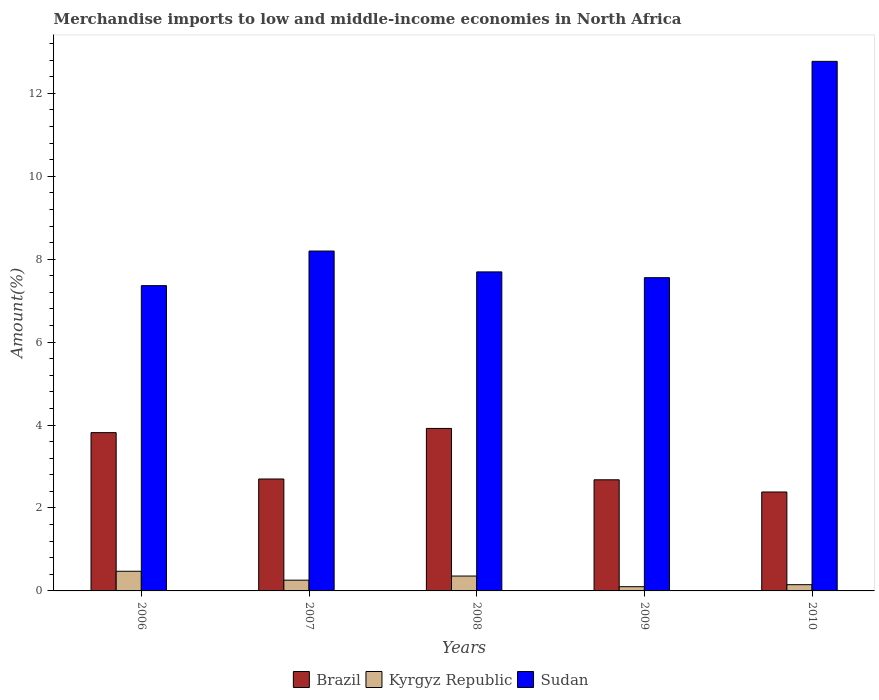How many different coloured bars are there?
Offer a terse response. 3. How many groups of bars are there?
Offer a terse response. 5. Are the number of bars per tick equal to the number of legend labels?
Your answer should be very brief. Yes. How many bars are there on the 4th tick from the left?
Give a very brief answer. 3. How many bars are there on the 5th tick from the right?
Give a very brief answer. 3. In how many cases, is the number of bars for a given year not equal to the number of legend labels?
Offer a terse response. 0. What is the percentage of amount earned from merchandise imports in Sudan in 2009?
Give a very brief answer. 7.55. Across all years, what is the maximum percentage of amount earned from merchandise imports in Kyrgyz Republic?
Your answer should be compact. 0.47. Across all years, what is the minimum percentage of amount earned from merchandise imports in Kyrgyz Republic?
Make the answer very short. 0.1. In which year was the percentage of amount earned from merchandise imports in Kyrgyz Republic maximum?
Your answer should be compact. 2006. What is the total percentage of amount earned from merchandise imports in Brazil in the graph?
Ensure brevity in your answer.  15.5. What is the difference between the percentage of amount earned from merchandise imports in Brazil in 2008 and that in 2010?
Provide a succinct answer. 1.53. What is the difference between the percentage of amount earned from merchandise imports in Sudan in 2009 and the percentage of amount earned from merchandise imports in Kyrgyz Republic in 2006?
Your answer should be very brief. 7.08. What is the average percentage of amount earned from merchandise imports in Kyrgyz Republic per year?
Give a very brief answer. 0.27. In the year 2010, what is the difference between the percentage of amount earned from merchandise imports in Sudan and percentage of amount earned from merchandise imports in Brazil?
Provide a succinct answer. 10.38. What is the ratio of the percentage of amount earned from merchandise imports in Kyrgyz Republic in 2008 to that in 2009?
Ensure brevity in your answer.  3.51. Is the difference between the percentage of amount earned from merchandise imports in Sudan in 2006 and 2008 greater than the difference between the percentage of amount earned from merchandise imports in Brazil in 2006 and 2008?
Ensure brevity in your answer.  No. What is the difference between the highest and the second highest percentage of amount earned from merchandise imports in Brazil?
Keep it short and to the point. 0.1. What is the difference between the highest and the lowest percentage of amount earned from merchandise imports in Brazil?
Provide a short and direct response. 1.53. What does the 2nd bar from the left in 2010 represents?
Offer a terse response. Kyrgyz Republic. Are all the bars in the graph horizontal?
Your answer should be compact. No. What is the difference between two consecutive major ticks on the Y-axis?
Provide a succinct answer. 2. Are the values on the major ticks of Y-axis written in scientific E-notation?
Offer a terse response. No. Does the graph contain any zero values?
Offer a very short reply. No. Does the graph contain grids?
Ensure brevity in your answer.  No. What is the title of the graph?
Give a very brief answer. Merchandise imports to low and middle-income economies in North Africa. What is the label or title of the X-axis?
Provide a short and direct response. Years. What is the label or title of the Y-axis?
Your answer should be very brief. Amount(%). What is the Amount(%) of Brazil in 2006?
Keep it short and to the point. 3.82. What is the Amount(%) in Kyrgyz Republic in 2006?
Keep it short and to the point. 0.47. What is the Amount(%) in Sudan in 2006?
Your response must be concise. 7.36. What is the Amount(%) in Brazil in 2007?
Keep it short and to the point. 2.7. What is the Amount(%) in Kyrgyz Republic in 2007?
Provide a short and direct response. 0.26. What is the Amount(%) of Sudan in 2007?
Offer a very short reply. 8.2. What is the Amount(%) of Brazil in 2008?
Ensure brevity in your answer.  3.92. What is the Amount(%) of Kyrgyz Republic in 2008?
Ensure brevity in your answer.  0.36. What is the Amount(%) of Sudan in 2008?
Keep it short and to the point. 7.69. What is the Amount(%) of Brazil in 2009?
Your response must be concise. 2.68. What is the Amount(%) in Kyrgyz Republic in 2009?
Offer a very short reply. 0.1. What is the Amount(%) in Sudan in 2009?
Your answer should be very brief. 7.55. What is the Amount(%) of Brazil in 2010?
Give a very brief answer. 2.39. What is the Amount(%) in Kyrgyz Republic in 2010?
Give a very brief answer. 0.15. What is the Amount(%) of Sudan in 2010?
Give a very brief answer. 12.77. Across all years, what is the maximum Amount(%) in Brazil?
Your answer should be very brief. 3.92. Across all years, what is the maximum Amount(%) in Kyrgyz Republic?
Make the answer very short. 0.47. Across all years, what is the maximum Amount(%) in Sudan?
Provide a short and direct response. 12.77. Across all years, what is the minimum Amount(%) in Brazil?
Give a very brief answer. 2.39. Across all years, what is the minimum Amount(%) of Kyrgyz Republic?
Keep it short and to the point. 0.1. Across all years, what is the minimum Amount(%) in Sudan?
Offer a very short reply. 7.36. What is the total Amount(%) in Brazil in the graph?
Keep it short and to the point. 15.5. What is the total Amount(%) in Kyrgyz Republic in the graph?
Make the answer very short. 1.34. What is the total Amount(%) of Sudan in the graph?
Offer a terse response. 43.58. What is the difference between the Amount(%) in Brazil in 2006 and that in 2007?
Provide a succinct answer. 1.12. What is the difference between the Amount(%) of Kyrgyz Republic in 2006 and that in 2007?
Your answer should be very brief. 0.21. What is the difference between the Amount(%) in Sudan in 2006 and that in 2007?
Make the answer very short. -0.83. What is the difference between the Amount(%) of Brazil in 2006 and that in 2008?
Offer a very short reply. -0.1. What is the difference between the Amount(%) of Kyrgyz Republic in 2006 and that in 2008?
Provide a succinct answer. 0.12. What is the difference between the Amount(%) in Sudan in 2006 and that in 2008?
Your response must be concise. -0.33. What is the difference between the Amount(%) in Brazil in 2006 and that in 2009?
Offer a very short reply. 1.14. What is the difference between the Amount(%) in Kyrgyz Republic in 2006 and that in 2009?
Your response must be concise. 0.37. What is the difference between the Amount(%) of Sudan in 2006 and that in 2009?
Your answer should be very brief. -0.19. What is the difference between the Amount(%) of Brazil in 2006 and that in 2010?
Your answer should be very brief. 1.43. What is the difference between the Amount(%) in Kyrgyz Republic in 2006 and that in 2010?
Provide a short and direct response. 0.32. What is the difference between the Amount(%) in Sudan in 2006 and that in 2010?
Your response must be concise. -5.41. What is the difference between the Amount(%) of Brazil in 2007 and that in 2008?
Give a very brief answer. -1.22. What is the difference between the Amount(%) of Kyrgyz Republic in 2007 and that in 2008?
Ensure brevity in your answer.  -0.1. What is the difference between the Amount(%) in Sudan in 2007 and that in 2008?
Offer a terse response. 0.5. What is the difference between the Amount(%) in Brazil in 2007 and that in 2009?
Provide a succinct answer. 0.02. What is the difference between the Amount(%) of Kyrgyz Republic in 2007 and that in 2009?
Your response must be concise. 0.16. What is the difference between the Amount(%) in Sudan in 2007 and that in 2009?
Offer a terse response. 0.64. What is the difference between the Amount(%) of Brazil in 2007 and that in 2010?
Your answer should be very brief. 0.31. What is the difference between the Amount(%) in Kyrgyz Republic in 2007 and that in 2010?
Your answer should be very brief. 0.11. What is the difference between the Amount(%) in Sudan in 2007 and that in 2010?
Your answer should be very brief. -4.57. What is the difference between the Amount(%) in Brazil in 2008 and that in 2009?
Provide a succinct answer. 1.24. What is the difference between the Amount(%) of Kyrgyz Republic in 2008 and that in 2009?
Your answer should be compact. 0.26. What is the difference between the Amount(%) in Sudan in 2008 and that in 2009?
Make the answer very short. 0.14. What is the difference between the Amount(%) of Brazil in 2008 and that in 2010?
Ensure brevity in your answer.  1.53. What is the difference between the Amount(%) of Kyrgyz Republic in 2008 and that in 2010?
Keep it short and to the point. 0.21. What is the difference between the Amount(%) in Sudan in 2008 and that in 2010?
Ensure brevity in your answer.  -5.08. What is the difference between the Amount(%) in Brazil in 2009 and that in 2010?
Your answer should be very brief. 0.29. What is the difference between the Amount(%) in Kyrgyz Republic in 2009 and that in 2010?
Offer a very short reply. -0.05. What is the difference between the Amount(%) of Sudan in 2009 and that in 2010?
Keep it short and to the point. -5.22. What is the difference between the Amount(%) of Brazil in 2006 and the Amount(%) of Kyrgyz Republic in 2007?
Make the answer very short. 3.56. What is the difference between the Amount(%) of Brazil in 2006 and the Amount(%) of Sudan in 2007?
Provide a succinct answer. -4.38. What is the difference between the Amount(%) of Kyrgyz Republic in 2006 and the Amount(%) of Sudan in 2007?
Ensure brevity in your answer.  -7.72. What is the difference between the Amount(%) of Brazil in 2006 and the Amount(%) of Kyrgyz Republic in 2008?
Ensure brevity in your answer.  3.46. What is the difference between the Amount(%) of Brazil in 2006 and the Amount(%) of Sudan in 2008?
Offer a terse response. -3.88. What is the difference between the Amount(%) of Kyrgyz Republic in 2006 and the Amount(%) of Sudan in 2008?
Keep it short and to the point. -7.22. What is the difference between the Amount(%) of Brazil in 2006 and the Amount(%) of Kyrgyz Republic in 2009?
Your response must be concise. 3.71. What is the difference between the Amount(%) in Brazil in 2006 and the Amount(%) in Sudan in 2009?
Give a very brief answer. -3.74. What is the difference between the Amount(%) of Kyrgyz Republic in 2006 and the Amount(%) of Sudan in 2009?
Provide a short and direct response. -7.08. What is the difference between the Amount(%) of Brazil in 2006 and the Amount(%) of Kyrgyz Republic in 2010?
Make the answer very short. 3.67. What is the difference between the Amount(%) in Brazil in 2006 and the Amount(%) in Sudan in 2010?
Offer a very short reply. -8.95. What is the difference between the Amount(%) of Kyrgyz Republic in 2006 and the Amount(%) of Sudan in 2010?
Ensure brevity in your answer.  -12.3. What is the difference between the Amount(%) in Brazil in 2007 and the Amount(%) in Kyrgyz Republic in 2008?
Your answer should be compact. 2.34. What is the difference between the Amount(%) of Brazil in 2007 and the Amount(%) of Sudan in 2008?
Ensure brevity in your answer.  -4.99. What is the difference between the Amount(%) of Kyrgyz Republic in 2007 and the Amount(%) of Sudan in 2008?
Ensure brevity in your answer.  -7.43. What is the difference between the Amount(%) of Brazil in 2007 and the Amount(%) of Kyrgyz Republic in 2009?
Offer a terse response. 2.6. What is the difference between the Amount(%) of Brazil in 2007 and the Amount(%) of Sudan in 2009?
Make the answer very short. -4.85. What is the difference between the Amount(%) in Kyrgyz Republic in 2007 and the Amount(%) in Sudan in 2009?
Make the answer very short. -7.29. What is the difference between the Amount(%) in Brazil in 2007 and the Amount(%) in Kyrgyz Republic in 2010?
Ensure brevity in your answer.  2.55. What is the difference between the Amount(%) in Brazil in 2007 and the Amount(%) in Sudan in 2010?
Ensure brevity in your answer.  -10.07. What is the difference between the Amount(%) in Kyrgyz Republic in 2007 and the Amount(%) in Sudan in 2010?
Provide a succinct answer. -12.51. What is the difference between the Amount(%) of Brazil in 2008 and the Amount(%) of Kyrgyz Republic in 2009?
Make the answer very short. 3.82. What is the difference between the Amount(%) of Brazil in 2008 and the Amount(%) of Sudan in 2009?
Provide a short and direct response. -3.64. What is the difference between the Amount(%) in Kyrgyz Republic in 2008 and the Amount(%) in Sudan in 2009?
Your answer should be very brief. -7.2. What is the difference between the Amount(%) in Brazil in 2008 and the Amount(%) in Kyrgyz Republic in 2010?
Keep it short and to the point. 3.77. What is the difference between the Amount(%) in Brazil in 2008 and the Amount(%) in Sudan in 2010?
Make the answer very short. -8.85. What is the difference between the Amount(%) in Kyrgyz Republic in 2008 and the Amount(%) in Sudan in 2010?
Make the answer very short. -12.41. What is the difference between the Amount(%) of Brazil in 2009 and the Amount(%) of Kyrgyz Republic in 2010?
Make the answer very short. 2.53. What is the difference between the Amount(%) in Brazil in 2009 and the Amount(%) in Sudan in 2010?
Offer a very short reply. -10.09. What is the difference between the Amount(%) of Kyrgyz Republic in 2009 and the Amount(%) of Sudan in 2010?
Provide a succinct answer. -12.67. What is the average Amount(%) of Brazil per year?
Make the answer very short. 3.1. What is the average Amount(%) in Kyrgyz Republic per year?
Offer a terse response. 0.27. What is the average Amount(%) in Sudan per year?
Your answer should be very brief. 8.72. In the year 2006, what is the difference between the Amount(%) in Brazil and Amount(%) in Kyrgyz Republic?
Your answer should be compact. 3.34. In the year 2006, what is the difference between the Amount(%) of Brazil and Amount(%) of Sudan?
Offer a terse response. -3.54. In the year 2006, what is the difference between the Amount(%) of Kyrgyz Republic and Amount(%) of Sudan?
Your answer should be very brief. -6.89. In the year 2007, what is the difference between the Amount(%) of Brazil and Amount(%) of Kyrgyz Republic?
Make the answer very short. 2.44. In the year 2007, what is the difference between the Amount(%) in Brazil and Amount(%) in Sudan?
Give a very brief answer. -5.5. In the year 2007, what is the difference between the Amount(%) in Kyrgyz Republic and Amount(%) in Sudan?
Provide a short and direct response. -7.94. In the year 2008, what is the difference between the Amount(%) in Brazil and Amount(%) in Kyrgyz Republic?
Your answer should be very brief. 3.56. In the year 2008, what is the difference between the Amount(%) in Brazil and Amount(%) in Sudan?
Make the answer very short. -3.77. In the year 2008, what is the difference between the Amount(%) of Kyrgyz Republic and Amount(%) of Sudan?
Provide a succinct answer. -7.33. In the year 2009, what is the difference between the Amount(%) in Brazil and Amount(%) in Kyrgyz Republic?
Keep it short and to the point. 2.58. In the year 2009, what is the difference between the Amount(%) of Brazil and Amount(%) of Sudan?
Make the answer very short. -4.87. In the year 2009, what is the difference between the Amount(%) of Kyrgyz Republic and Amount(%) of Sudan?
Your answer should be very brief. -7.45. In the year 2010, what is the difference between the Amount(%) in Brazil and Amount(%) in Kyrgyz Republic?
Ensure brevity in your answer.  2.24. In the year 2010, what is the difference between the Amount(%) of Brazil and Amount(%) of Sudan?
Ensure brevity in your answer.  -10.38. In the year 2010, what is the difference between the Amount(%) in Kyrgyz Republic and Amount(%) in Sudan?
Keep it short and to the point. -12.62. What is the ratio of the Amount(%) of Brazil in 2006 to that in 2007?
Provide a short and direct response. 1.41. What is the ratio of the Amount(%) in Kyrgyz Republic in 2006 to that in 2007?
Offer a very short reply. 1.83. What is the ratio of the Amount(%) in Sudan in 2006 to that in 2007?
Provide a succinct answer. 0.9. What is the ratio of the Amount(%) in Brazil in 2006 to that in 2008?
Keep it short and to the point. 0.97. What is the ratio of the Amount(%) in Kyrgyz Republic in 2006 to that in 2008?
Offer a terse response. 1.32. What is the ratio of the Amount(%) of Sudan in 2006 to that in 2008?
Offer a very short reply. 0.96. What is the ratio of the Amount(%) of Brazil in 2006 to that in 2009?
Ensure brevity in your answer.  1.42. What is the ratio of the Amount(%) in Kyrgyz Republic in 2006 to that in 2009?
Offer a very short reply. 4.64. What is the ratio of the Amount(%) in Sudan in 2006 to that in 2009?
Ensure brevity in your answer.  0.97. What is the ratio of the Amount(%) of Brazil in 2006 to that in 2010?
Offer a terse response. 1.6. What is the ratio of the Amount(%) of Kyrgyz Republic in 2006 to that in 2010?
Your answer should be compact. 3.15. What is the ratio of the Amount(%) of Sudan in 2006 to that in 2010?
Offer a very short reply. 0.58. What is the ratio of the Amount(%) in Brazil in 2007 to that in 2008?
Provide a short and direct response. 0.69. What is the ratio of the Amount(%) in Kyrgyz Republic in 2007 to that in 2008?
Offer a terse response. 0.72. What is the ratio of the Amount(%) in Sudan in 2007 to that in 2008?
Ensure brevity in your answer.  1.07. What is the ratio of the Amount(%) in Brazil in 2007 to that in 2009?
Offer a very short reply. 1.01. What is the ratio of the Amount(%) in Kyrgyz Republic in 2007 to that in 2009?
Give a very brief answer. 2.54. What is the ratio of the Amount(%) in Sudan in 2007 to that in 2009?
Your answer should be compact. 1.08. What is the ratio of the Amount(%) in Brazil in 2007 to that in 2010?
Your answer should be compact. 1.13. What is the ratio of the Amount(%) of Kyrgyz Republic in 2007 to that in 2010?
Provide a succinct answer. 1.72. What is the ratio of the Amount(%) in Sudan in 2007 to that in 2010?
Keep it short and to the point. 0.64. What is the ratio of the Amount(%) of Brazil in 2008 to that in 2009?
Your answer should be very brief. 1.46. What is the ratio of the Amount(%) in Kyrgyz Republic in 2008 to that in 2009?
Your response must be concise. 3.51. What is the ratio of the Amount(%) of Sudan in 2008 to that in 2009?
Your answer should be compact. 1.02. What is the ratio of the Amount(%) in Brazil in 2008 to that in 2010?
Offer a very short reply. 1.64. What is the ratio of the Amount(%) in Kyrgyz Republic in 2008 to that in 2010?
Your response must be concise. 2.38. What is the ratio of the Amount(%) in Sudan in 2008 to that in 2010?
Your response must be concise. 0.6. What is the ratio of the Amount(%) of Brazil in 2009 to that in 2010?
Keep it short and to the point. 1.12. What is the ratio of the Amount(%) of Kyrgyz Republic in 2009 to that in 2010?
Give a very brief answer. 0.68. What is the ratio of the Amount(%) of Sudan in 2009 to that in 2010?
Offer a very short reply. 0.59. What is the difference between the highest and the second highest Amount(%) of Brazil?
Your response must be concise. 0.1. What is the difference between the highest and the second highest Amount(%) of Kyrgyz Republic?
Your response must be concise. 0.12. What is the difference between the highest and the second highest Amount(%) in Sudan?
Offer a terse response. 4.57. What is the difference between the highest and the lowest Amount(%) in Brazil?
Your response must be concise. 1.53. What is the difference between the highest and the lowest Amount(%) in Kyrgyz Republic?
Offer a very short reply. 0.37. What is the difference between the highest and the lowest Amount(%) in Sudan?
Provide a short and direct response. 5.41. 